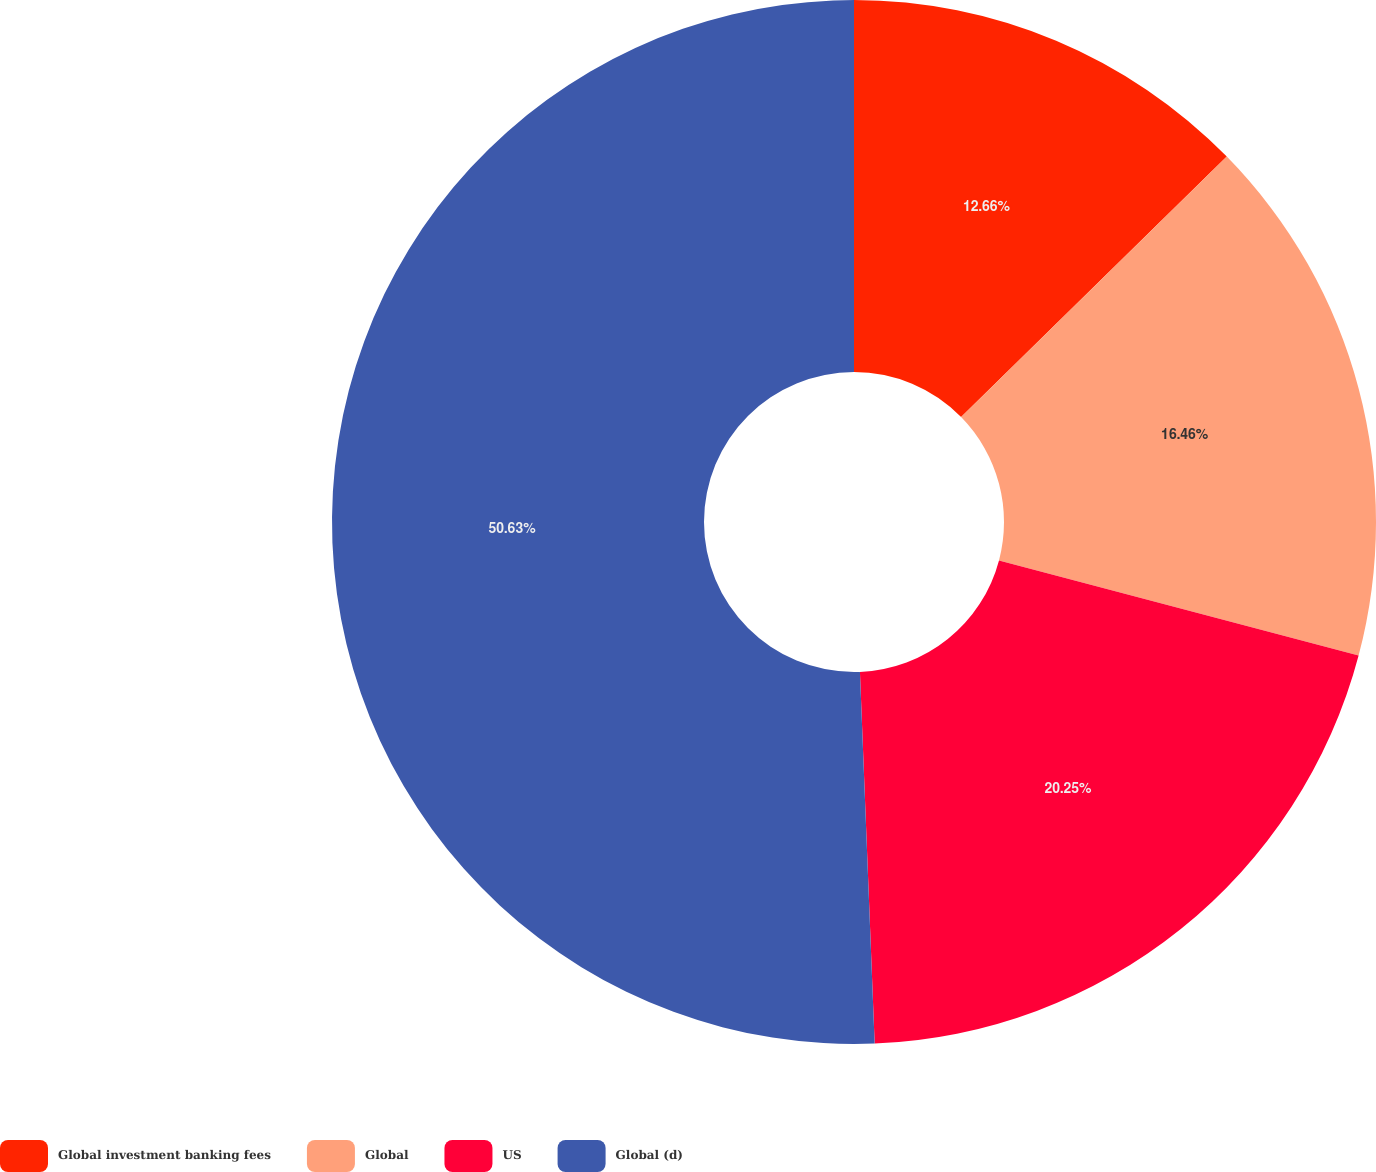<chart> <loc_0><loc_0><loc_500><loc_500><pie_chart><fcel>Global investment banking fees<fcel>Global<fcel>US<fcel>Global (d)<nl><fcel>12.66%<fcel>16.46%<fcel>20.25%<fcel>50.63%<nl></chart> 